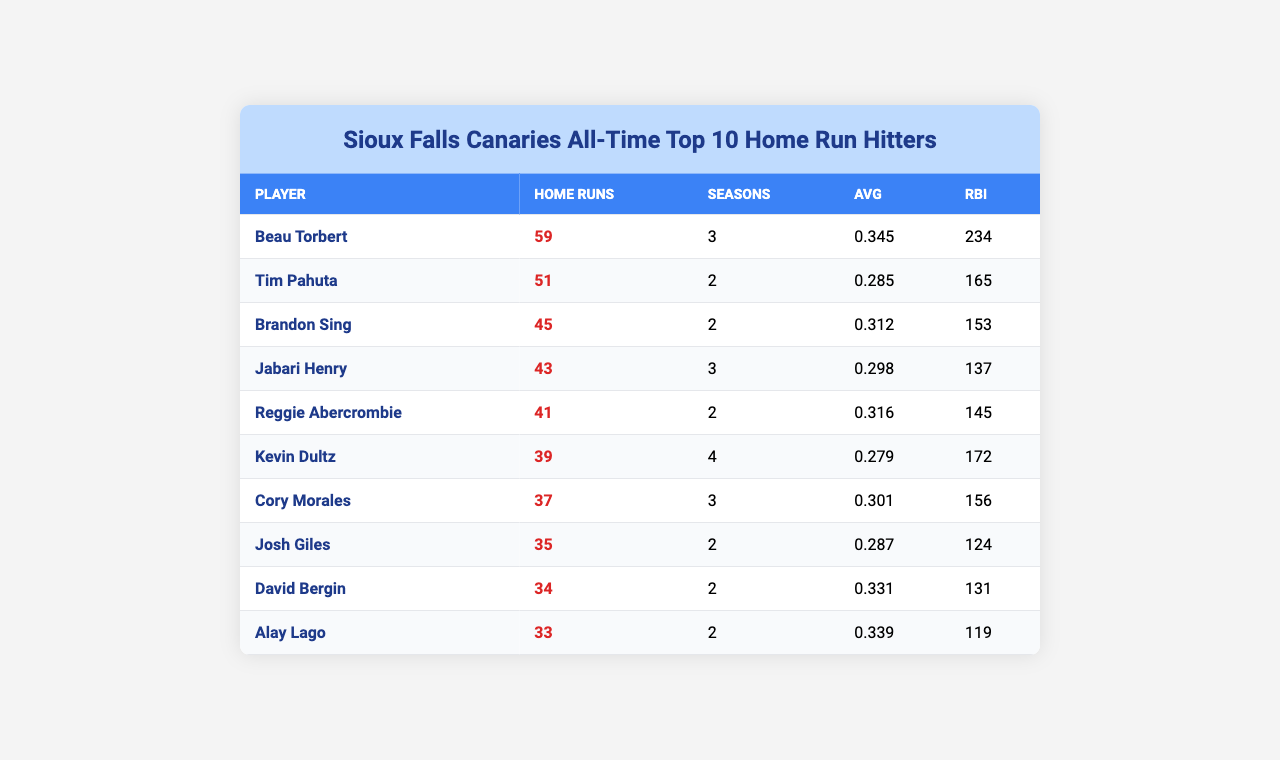What is the name of the player with the most home runs? According to the table, Beau Torbert has the highest number of home runs, totaling 59.
Answer: Beau Torbert How many home runs did Tim Pahuta hit? The table shows that Tim Pahuta hit 51 home runs.
Answer: 51 Which player has the highest batting average? By looking at the averages, Beau Torbert has the highest average at 0.345.
Answer: 0.345 How many seasons did Reggie Abercrombie play? The table indicates that Reggie Abercrombie played for 2 seasons.
Answer: 2 What is the total number of home runs hit by Kevin Dultz and Cory Morales? Kevin Dultz hit 39 home runs and Cory Morales hit 37 home runs, so the total is 39 + 37 = 76.
Answer: 76 What is the average number of home runs for the top 10 players? To find the average, sum up all the home runs (59 + 51 + 45 + 43 + 41 + 39 + 37 + 35 + 34 + 33 =  418) and divide by 10, which gives 418/10 = 41.8.
Answer: 41.8 Is the player with the most home runs also the one with the most RBIs? Beau Torbert has the most home runs (59), and he also has 234 RBIs. No other player has more RBIs than him, confirming he holds both titles.
Answer: Yes How many players have a batting average above 0.300? By observing the table, there are 5 players with averages above 0.300: Beau Torbert, Reggie Abercrombie, Kevin Dultz, Cory Morales, and Alay Lago.
Answer: 5 Which player had the least number of home runs? The table shows that Alay Lago had the least number of home runs, with a total of 33.
Answer: Alay Lago What combination of home runs and RBIs does Jabari Henry have compared to Brandon Sing? Jabari Henry hit 43 home runs and has 137 RBIs, while Brandon Sing hit 45 home runs and has 153 RBIs. Comparing them, Brandon Sing has 2 more home runs and 16 more RBIs than Jabari Henry.
Answer: Brandon Sing has more in both categories 